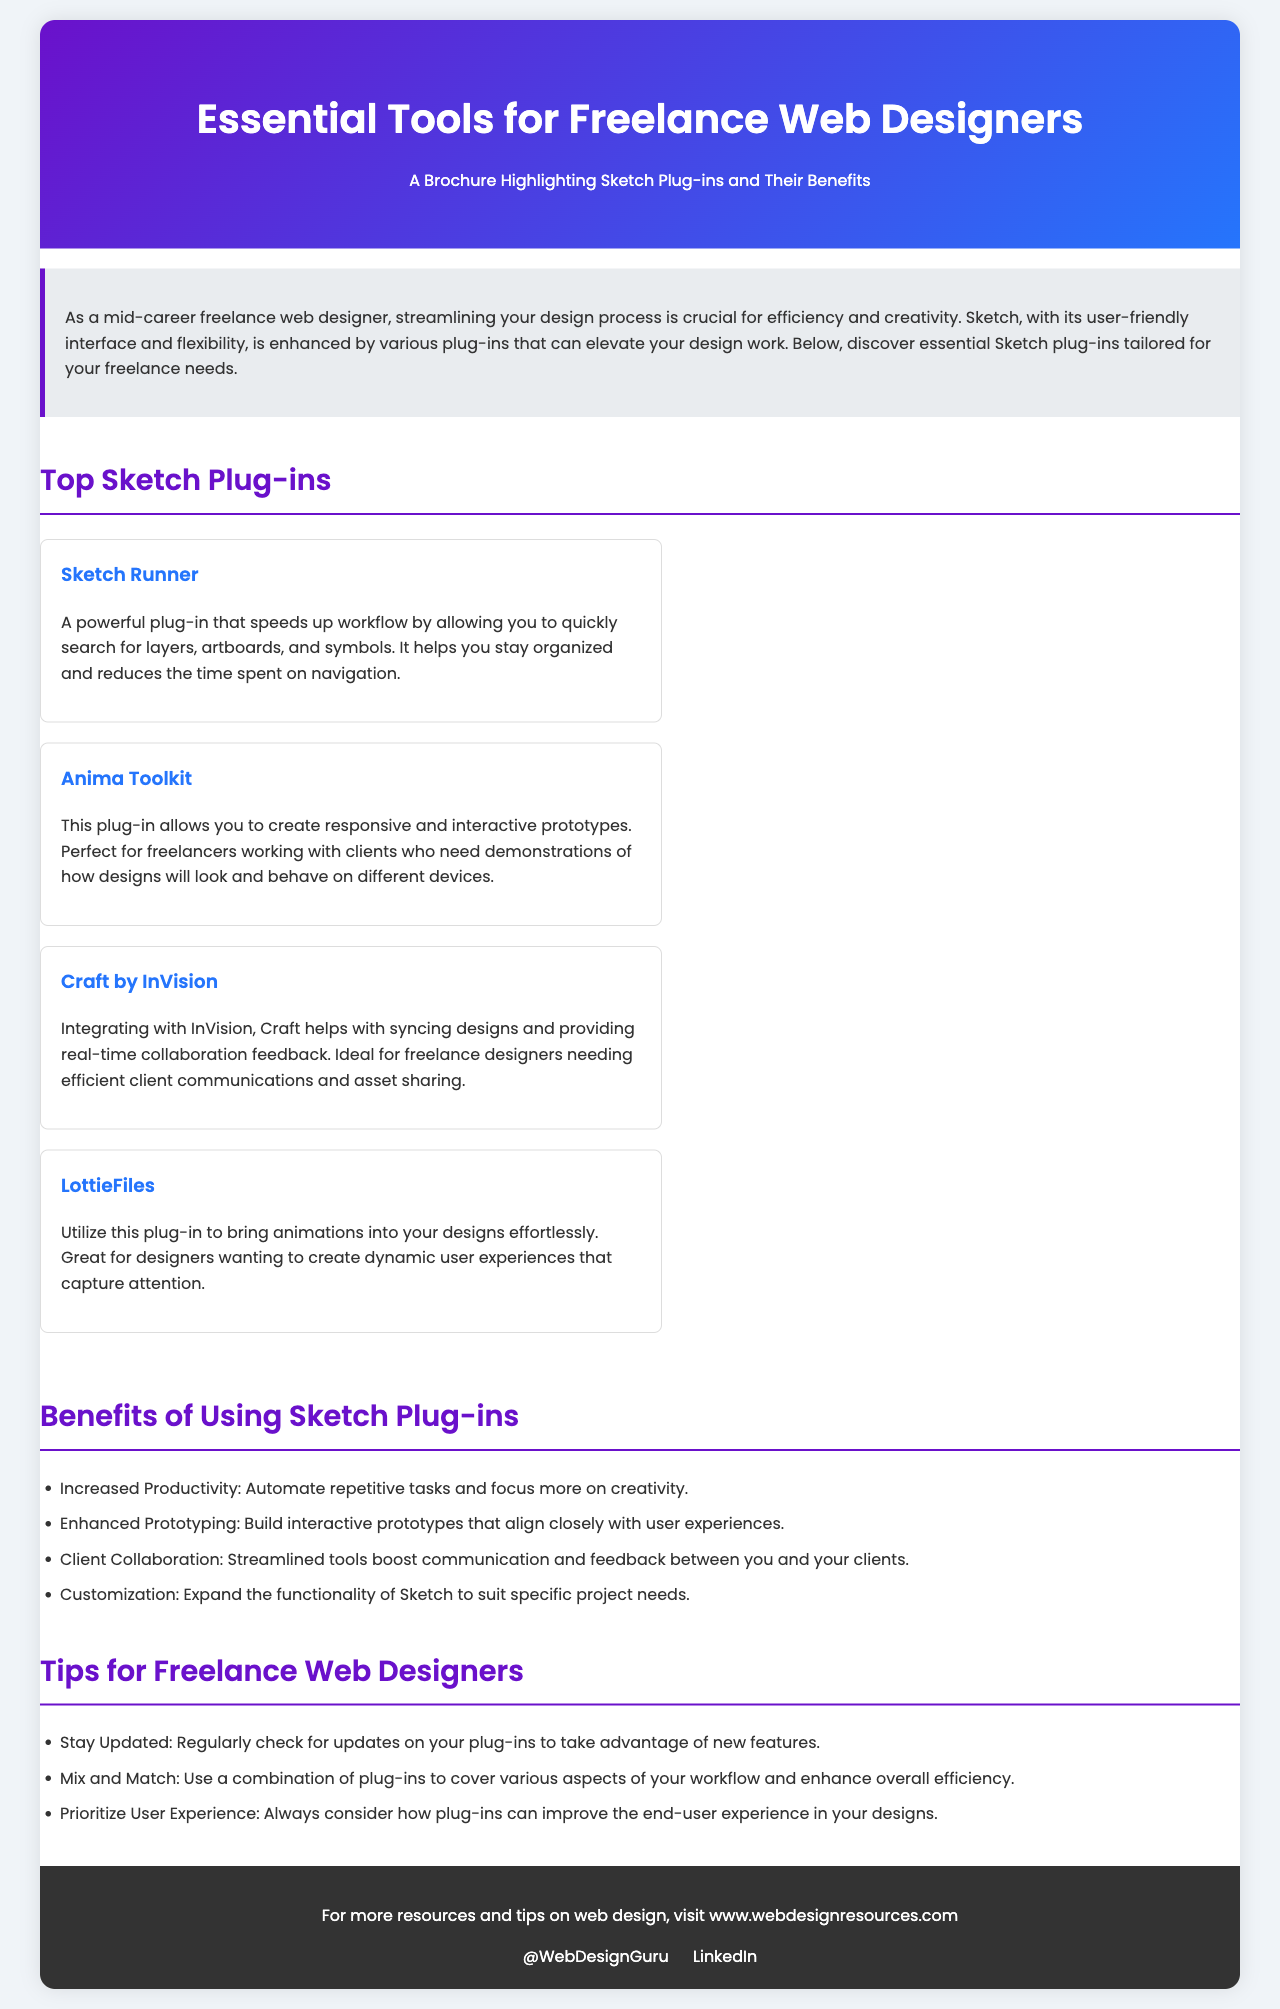What is the title of the brochure? The title is prominently displayed in the header section of the brochure.
Answer: Essential Tools for Freelance Web Designers What is the plug-in that speeds up workflow? This information can be found under the "Top Sketch Plug-ins" section where each plug-in is described.
Answer: Sketch Runner What is one benefit of using Sketch plug-ins? The benefits are listed in a bullet format under the "Benefits of Using Sketch Plug-ins" section.
Answer: Increased Productivity Which plug-in allows for responsive prototypes? The plug-in specifically mentioned for this function is described in the "Top Sketch Plug-ins" section.
Answer: Anima Toolkit How many plug-ins are highlighted in the brochure? This can be calculated by counting the number of individual plug-in entries under the "Top Sketch Plug-ins" section.
Answer: Four What should designers prioritize according to the tips? The tips section includes advice relevant to enhancing design work.
Answer: User Experience What is the background color of the brochure? This can be inferred from the style definitions applied to the body of the document.
Answer: White 